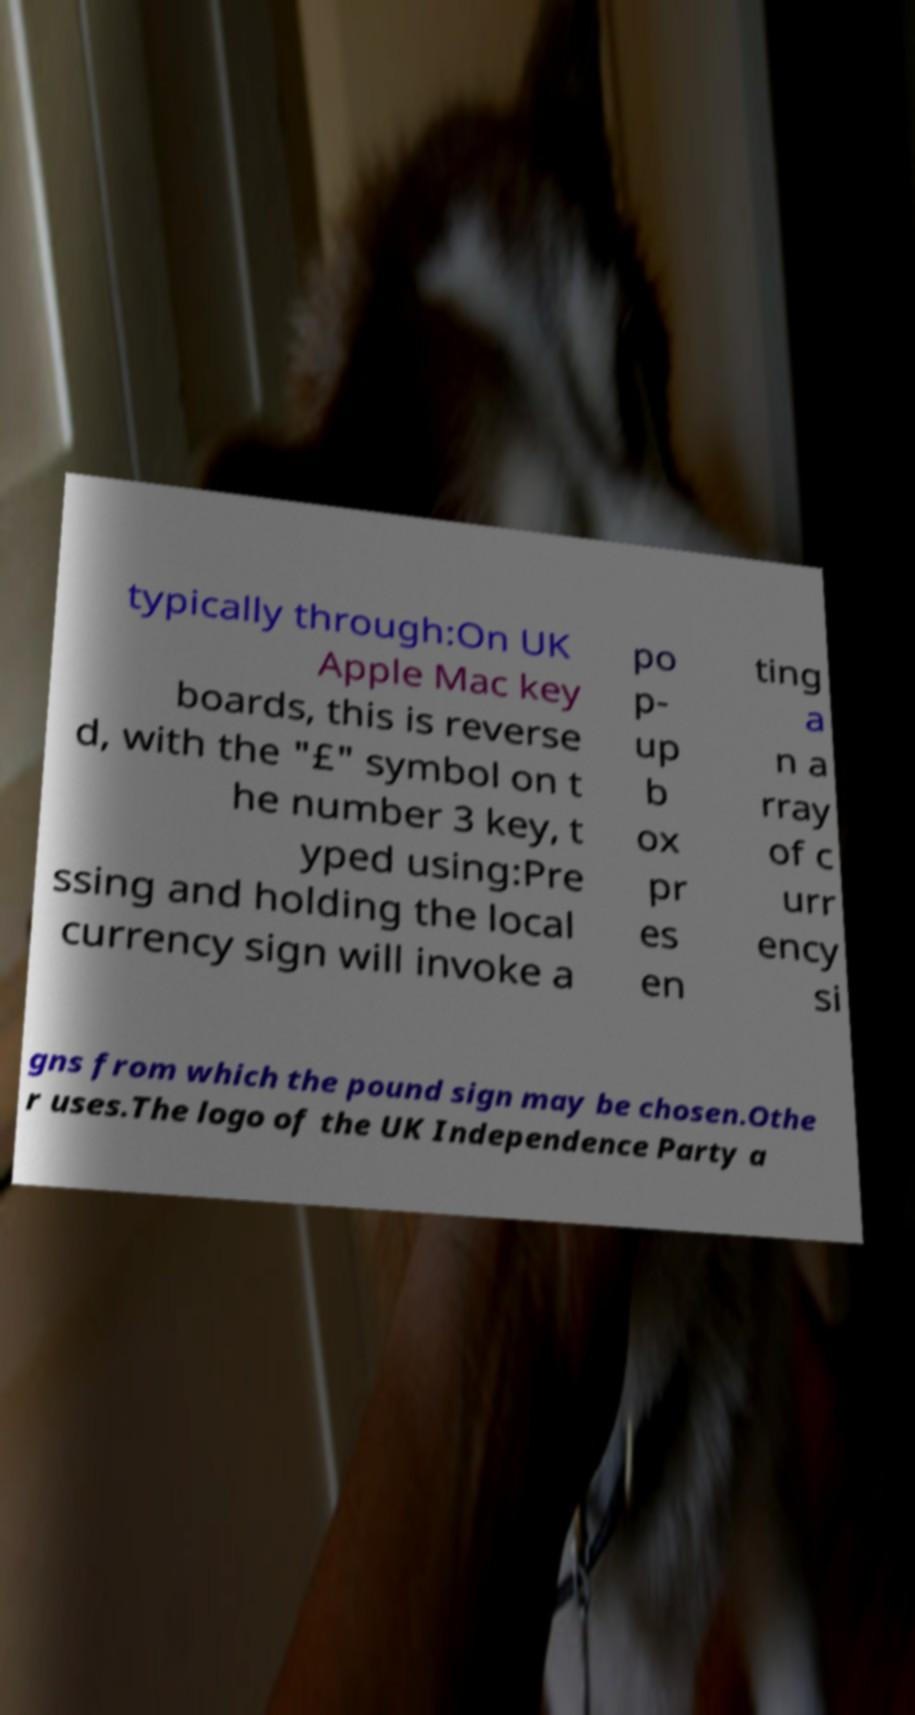Please identify and transcribe the text found in this image. typically through:On UK Apple Mac key boards, this is reverse d, with the "£" symbol on t he number 3 key, t yped using:Pre ssing and holding the local currency sign will invoke a po p- up b ox pr es en ting a n a rray of c urr ency si gns from which the pound sign may be chosen.Othe r uses.The logo of the UK Independence Party a 